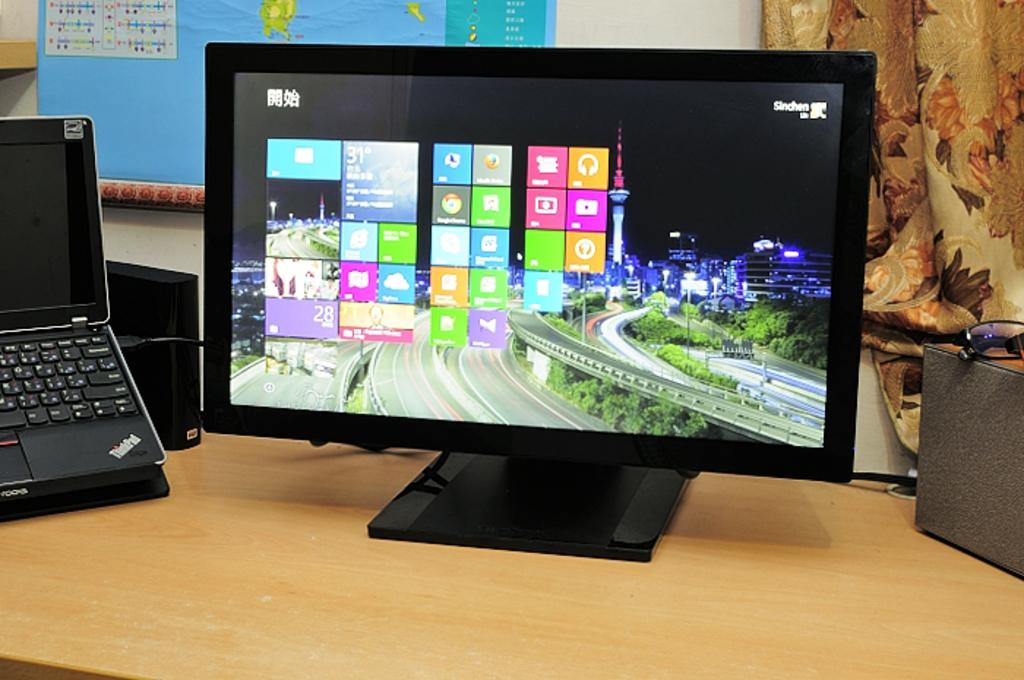<image>
Relay a brief, clear account of the picture shown. a computer monitor on a windows screen that says sinchen on it 